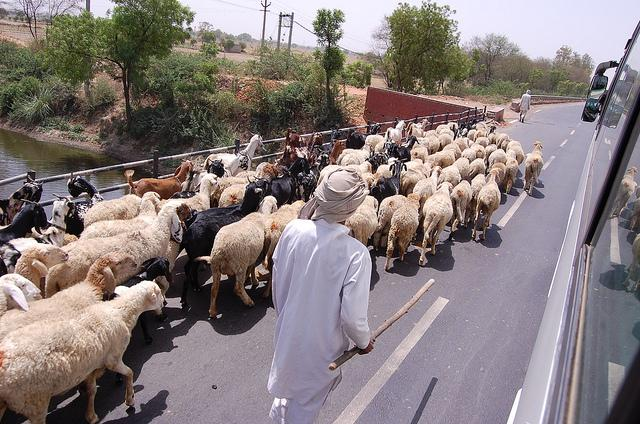What side of the rest is usually best for passing?

Choices:
A) under
B) right
C) left
D) over left 